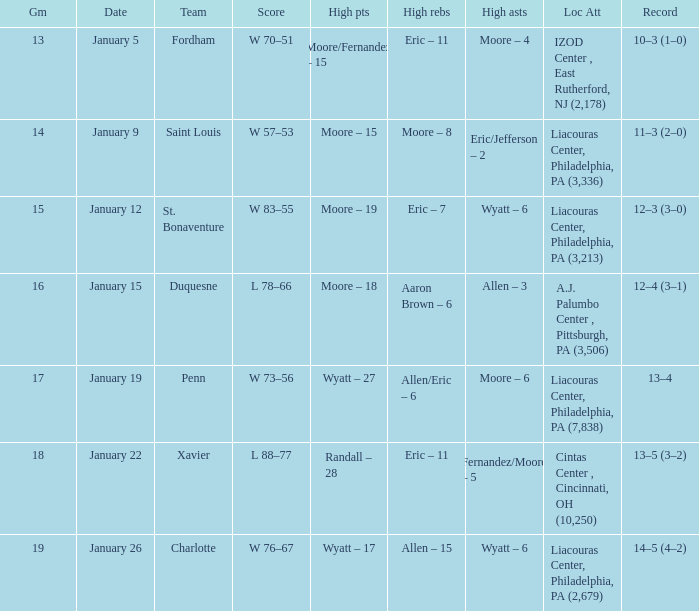Who had the most assists and how many did they have on January 5? Moore – 4. 